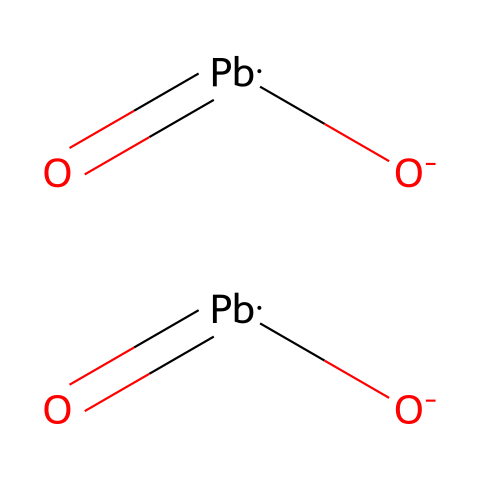how many lead atoms are present in the chemical structure? The SMILES representation indicates two lead atoms (Pb) are present, as each lead atom is denoted by "Pb" in the structure.
Answer: two what is the oxidation state of lead in this compound? The presence of the oxide anions observing the structure indicates that lead is in the +2 oxidation state, as it forms bonds with two oxygen atoms typically seen with lead-based compounds.
Answer: +2 how many oxygen atoms are in the chemical structure? The structure features two distinct oxygen atoms (O) from the anionic parts and is represented twice in the SMILES. Thus, there are four oxygen atoms in total.
Answer: four what type of bond connects the lead and oxygen atoms? The bond between lead and oxygen is covalent, as lead typically forms covalent bonds with oxygen due to the nature of its compounds.
Answer: covalent what is the likely use of this compound in ancient Egypt? Given its composition, the compound is likely used as an eye cosmetic, such as in kohl, which historically includes lead compounds for aesthetic purposes.
Answer: cosmetic how does the structure suggest toxicity associated with this compound? The presence of lead is a key indicator of potential toxicity, as lead is well-known for its harmful effects on human health and is particularly concerning in cosmetics meant for application near the eyes.
Answer: toxicity 